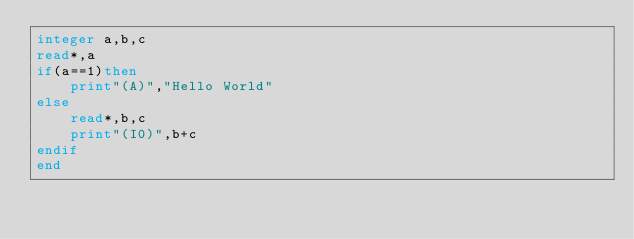Convert code to text. <code><loc_0><loc_0><loc_500><loc_500><_FORTRAN_>integer a,b,c
read*,a
if(a==1)then
	print"(A)","Hello World"
else
	read*,b,c
	print"(I0)",b+c
endif
end</code> 